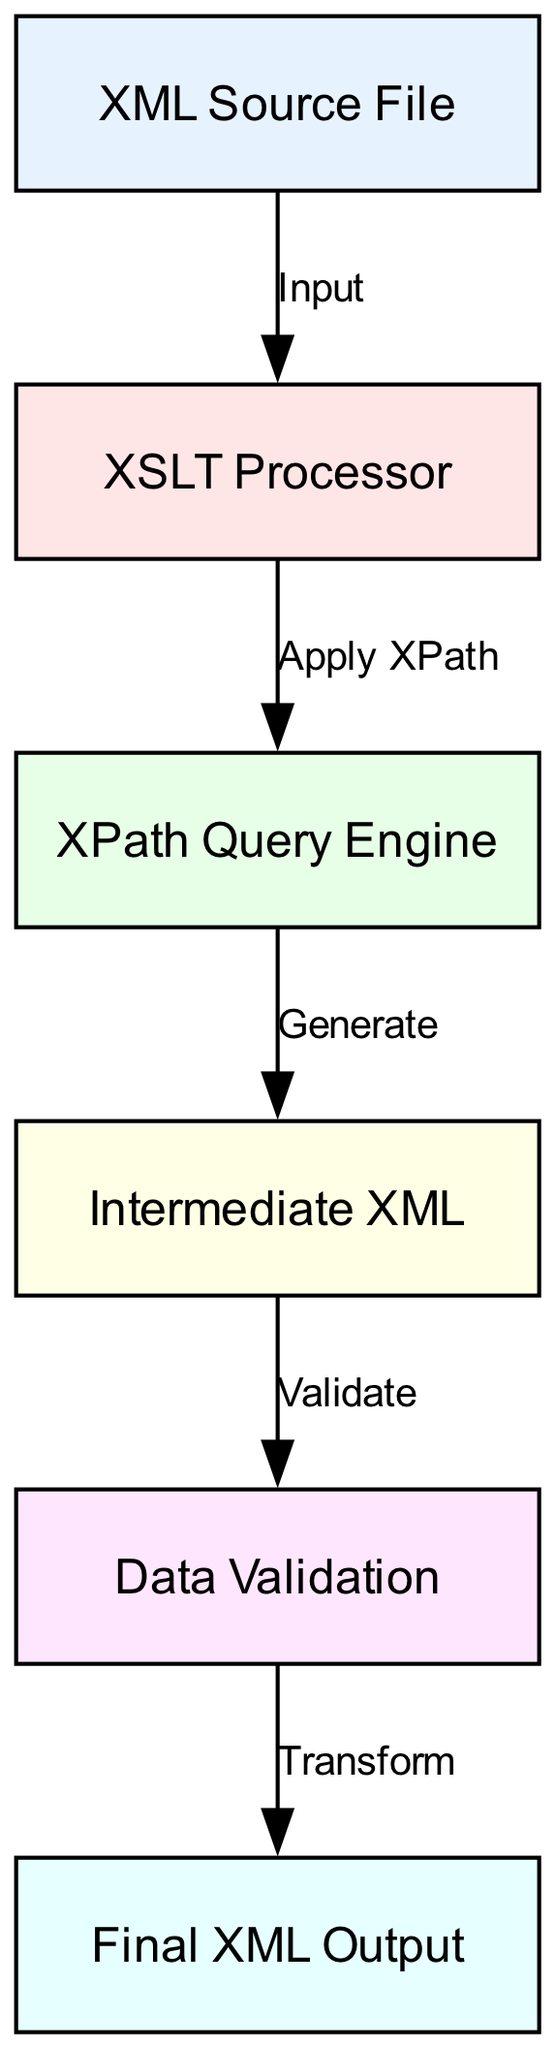What's the number of nodes in the diagram? The diagram displays six distinct nodes which are labeled with specific entities involved in the XML transformation process. By counting each unique label in the nodes list, we confirm there are six.
Answer: six What is the label of node 4? Node 4 in the diagram is labeled "Intermediate XML," which indicates its function as a temporary data structure during the transformation process.
Answer: Intermediate XML Which node does the "Apply XPath" edge connect? The "Apply XPath" edge connects node 2 (XSLT Processor) to node 3 (XPath Query Engine), indicating the flow of data as the processing moves from XSLT processing to XPath application.
Answer: XPath Query Engine What comes after "Data Validation" in the workflow? Following "Data Validation," the next step in the workflow is the "Final XML Output," which represents the end product after the validation checks have been performed.
Answer: Final XML Output What is the input for the XSLT Processor? The input for the XSLT Processor is the "XML Source File," as indicated by the directed edge from node 1 to node 2 in the diagram, showing the flow of data into the processor.
Answer: XML Source File How many edges are present in the diagram? The diagram includes five edges, which represent the various processing steps that connect the different nodes in the XML transformation workflow.
Answer: five Which node is responsible for generating the Intermediate XML? The "XPath Query Engine," which is node 3, is responsible for generating the Intermediate XML, as indicated by the edge labeled "Generate" that connects it to node 4.
Answer: XPath Query Engine What role does the XSLT Processor play in the workflow? The XSLT Processor acts as a critical intermediary that applies transformations to the XML Source File, leading the processing chain to the XPath Query Engine.
Answer: Transformation Which node validates the XML data? The node designated for validating the XML data is "Data Validation," which ensures that the intermediate XML conforms to specified rules or schemas before proceeding to generate the final output.
Answer: Data Validation 